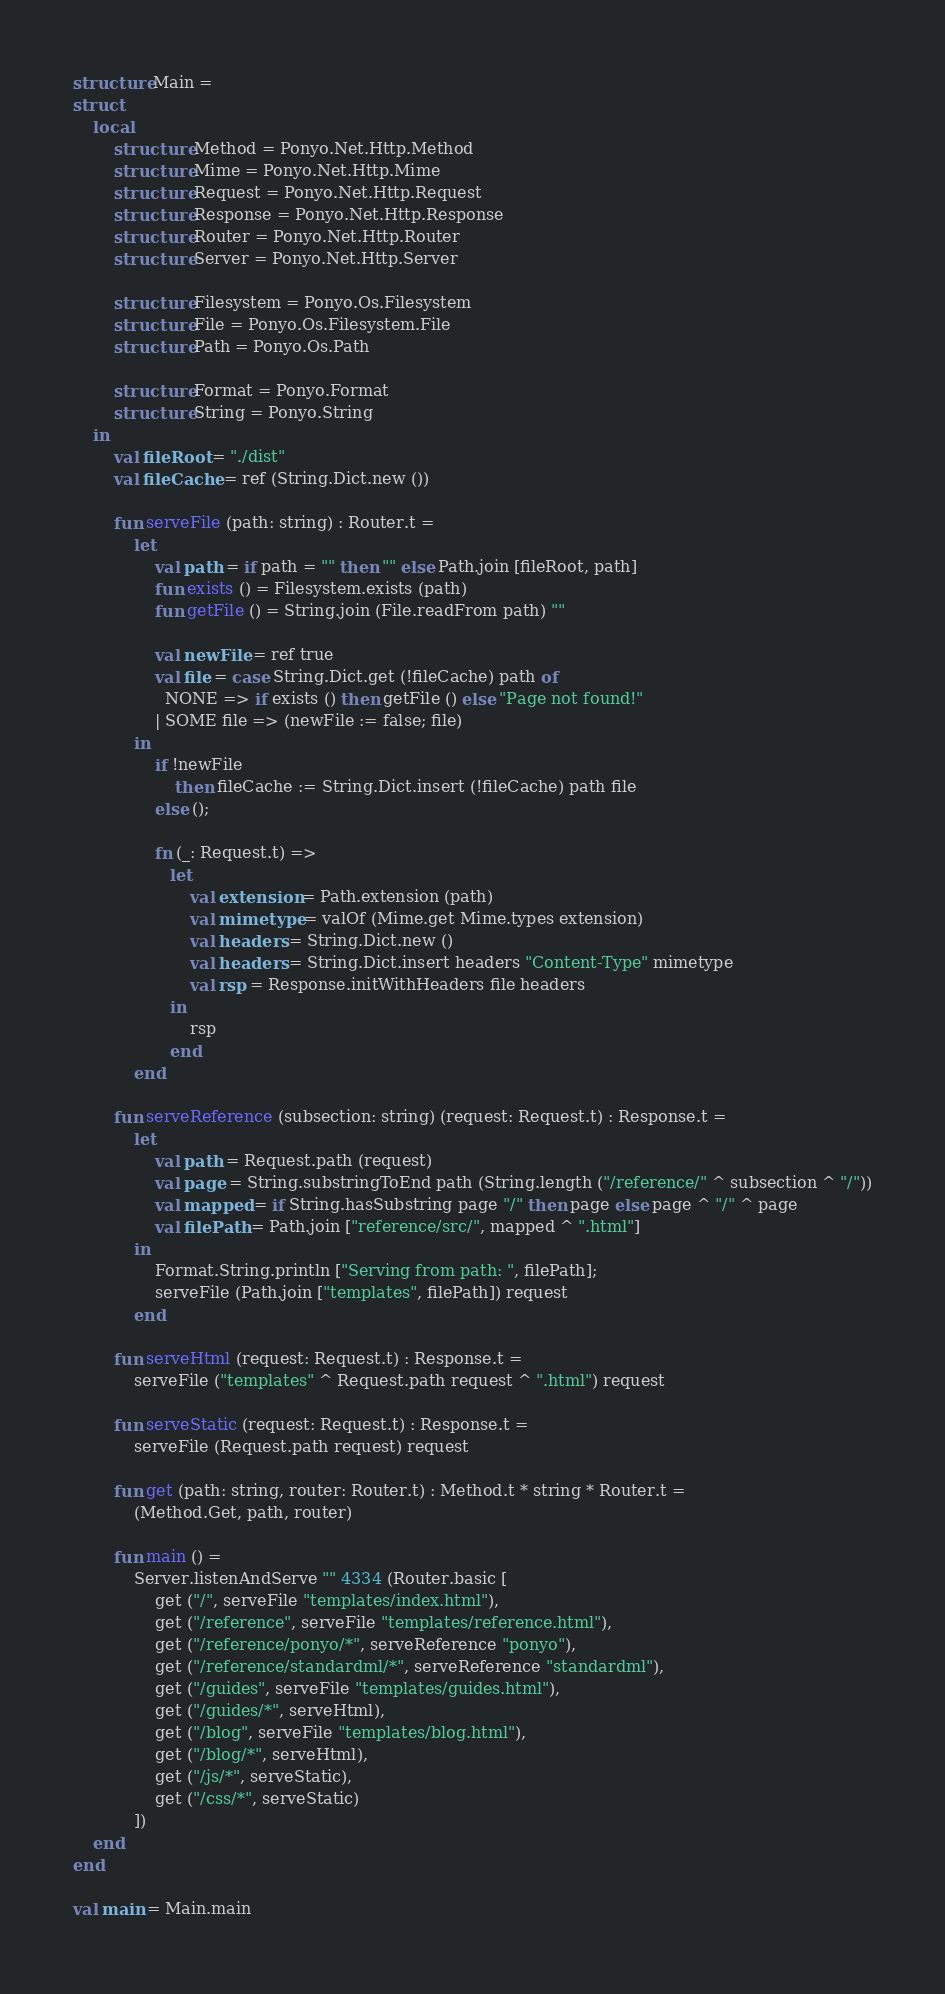Convert code to text. <code><loc_0><loc_0><loc_500><loc_500><_SML_>structure Main =
struct
    local
        structure Method = Ponyo.Net.Http.Method
        structure Mime = Ponyo.Net.Http.Mime
        structure Request = Ponyo.Net.Http.Request
        structure Response = Ponyo.Net.Http.Response
        structure Router = Ponyo.Net.Http.Router
        structure Server = Ponyo.Net.Http.Server

        structure Filesystem = Ponyo.Os.Filesystem
        structure File = Ponyo.Os.Filesystem.File
        structure Path = Ponyo.Os.Path

        structure Format = Ponyo.Format
        structure String = Ponyo.String
    in
        val fileRoot = "./dist"
        val fileCache = ref (String.Dict.new ())

        fun serveFile (path: string) : Router.t =
            let
                val path = if path = "" then "" else Path.join [fileRoot, path]
                fun exists () = Filesystem.exists (path)
                fun getFile () = String.join (File.readFrom path) ""

                val newFile = ref true
                val file = case String.Dict.get (!fileCache) path of
                  NONE => if exists () then getFile () else "Page not found!"
                | SOME file => (newFile := false; file)
            in
                if !newFile
                    then fileCache := String.Dict.insert (!fileCache) path file
                else ();

                fn (_: Request.t) =>
                   let
                       val extension = Path.extension (path)
                       val mimetype = valOf (Mime.get Mime.types extension)
                       val headers = String.Dict.new ()
                       val headers = String.Dict.insert headers "Content-Type" mimetype
                       val rsp = Response.initWithHeaders file headers
                   in
                       rsp
                   end
            end

        fun serveReference (subsection: string) (request: Request.t) : Response.t =
            let
                val path = Request.path (request)
                val page = String.substringToEnd path (String.length ("/reference/" ^ subsection ^ "/"))
                val mapped = if String.hasSubstring page "/" then page else page ^ "/" ^ page
                val filePath = Path.join ["reference/src/", mapped ^ ".html"]
            in
                Format.String.println ["Serving from path: ", filePath];
                serveFile (Path.join ["templates", filePath]) request
            end

        fun serveHtml (request: Request.t) : Response.t =
            serveFile ("templates" ^ Request.path request ^ ".html") request

        fun serveStatic (request: Request.t) : Response.t =
            serveFile (Request.path request) request

        fun get (path: string, router: Router.t) : Method.t * string * Router.t =
            (Method.Get, path, router)

        fun main () =
            Server.listenAndServe "" 4334 (Router.basic [
                get ("/", serveFile "templates/index.html"),
                get ("/reference", serveFile "templates/reference.html"),
                get ("/reference/ponyo/*", serveReference "ponyo"),
                get ("/reference/standardml/*", serveReference "standardml"),
                get ("/guides", serveFile "templates/guides.html"),
                get ("/guides/*", serveHtml),
                get ("/blog", serveFile "templates/blog.html"),
                get ("/blog/*", serveHtml),
                get ("/js/*", serveStatic),
                get ("/css/*", serveStatic)
            ])
    end
end

val main = Main.main
</code> 